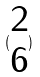Convert formula to latex. <formula><loc_0><loc_0><loc_500><loc_500>( \begin{matrix} 2 \\ 6 \end{matrix} )</formula> 